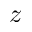Convert formula to latex. <formula><loc_0><loc_0><loc_500><loc_500>z</formula> 